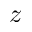Convert formula to latex. <formula><loc_0><loc_0><loc_500><loc_500>z</formula> 